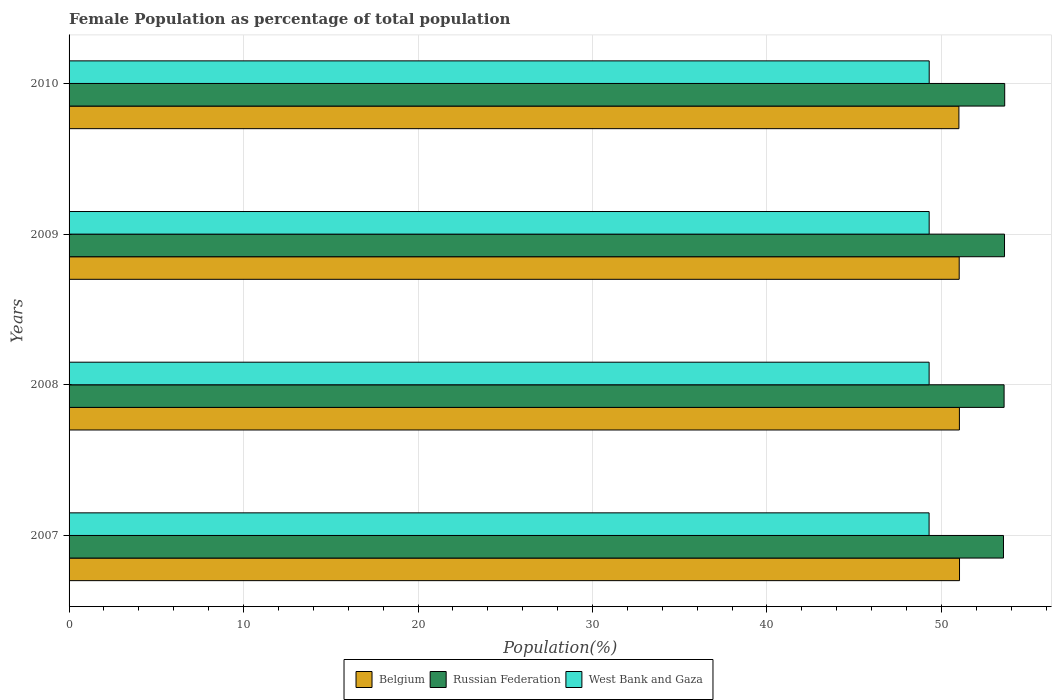How many groups of bars are there?
Your response must be concise. 4. Are the number of bars on each tick of the Y-axis equal?
Provide a succinct answer. Yes. How many bars are there on the 3rd tick from the top?
Your answer should be very brief. 3. How many bars are there on the 4th tick from the bottom?
Offer a terse response. 3. What is the label of the 2nd group of bars from the top?
Keep it short and to the point. 2009. In how many cases, is the number of bars for a given year not equal to the number of legend labels?
Provide a short and direct response. 0. What is the female population in in West Bank and Gaza in 2007?
Your response must be concise. 49.29. Across all years, what is the maximum female population in in Belgium?
Give a very brief answer. 51.03. Across all years, what is the minimum female population in in Russian Federation?
Offer a terse response. 53.55. In which year was the female population in in Russian Federation maximum?
Your answer should be very brief. 2010. What is the total female population in in West Bank and Gaza in the graph?
Your answer should be very brief. 197.17. What is the difference between the female population in in Belgium in 2008 and that in 2009?
Your answer should be compact. 0.01. What is the difference between the female population in in West Bank and Gaza in 2010 and the female population in in Russian Federation in 2008?
Offer a very short reply. -4.29. What is the average female population in in West Bank and Gaza per year?
Provide a short and direct response. 49.29. In the year 2010, what is the difference between the female population in in West Bank and Gaza and female population in in Russian Federation?
Provide a short and direct response. -4.33. What is the ratio of the female population in in Russian Federation in 2007 to that in 2009?
Your response must be concise. 1. Is the female population in in Russian Federation in 2008 less than that in 2010?
Offer a terse response. Yes. What is the difference between the highest and the second highest female population in in West Bank and Gaza?
Ensure brevity in your answer.  0. What is the difference between the highest and the lowest female population in in West Bank and Gaza?
Your answer should be compact. 0.01. What does the 2nd bar from the top in 2008 represents?
Keep it short and to the point. Russian Federation. What does the 2nd bar from the bottom in 2009 represents?
Offer a terse response. Russian Federation. Are all the bars in the graph horizontal?
Offer a terse response. Yes. Does the graph contain any zero values?
Keep it short and to the point. No. Does the graph contain grids?
Offer a terse response. Yes. Where does the legend appear in the graph?
Your answer should be compact. Bottom center. How many legend labels are there?
Your answer should be very brief. 3. What is the title of the graph?
Give a very brief answer. Female Population as percentage of total population. What is the label or title of the X-axis?
Give a very brief answer. Population(%). What is the label or title of the Y-axis?
Your answer should be compact. Years. What is the Population(%) in Belgium in 2007?
Your answer should be compact. 51.03. What is the Population(%) of Russian Federation in 2007?
Ensure brevity in your answer.  53.55. What is the Population(%) of West Bank and Gaza in 2007?
Your response must be concise. 49.29. What is the Population(%) of Belgium in 2008?
Ensure brevity in your answer.  51.03. What is the Population(%) of Russian Federation in 2008?
Keep it short and to the point. 53.59. What is the Population(%) of West Bank and Gaza in 2008?
Offer a terse response. 49.29. What is the Population(%) of Belgium in 2009?
Make the answer very short. 51.02. What is the Population(%) of Russian Federation in 2009?
Ensure brevity in your answer.  53.61. What is the Population(%) in West Bank and Gaza in 2009?
Your answer should be compact. 49.29. What is the Population(%) in Belgium in 2010?
Your answer should be very brief. 51. What is the Population(%) of Russian Federation in 2010?
Provide a short and direct response. 53.62. What is the Population(%) of West Bank and Gaza in 2010?
Your answer should be very brief. 49.3. Across all years, what is the maximum Population(%) in Belgium?
Ensure brevity in your answer.  51.03. Across all years, what is the maximum Population(%) of Russian Federation?
Keep it short and to the point. 53.62. Across all years, what is the maximum Population(%) of West Bank and Gaza?
Provide a short and direct response. 49.3. Across all years, what is the minimum Population(%) of Belgium?
Give a very brief answer. 51. Across all years, what is the minimum Population(%) in Russian Federation?
Your answer should be very brief. 53.55. Across all years, what is the minimum Population(%) in West Bank and Gaza?
Provide a short and direct response. 49.29. What is the total Population(%) of Belgium in the graph?
Ensure brevity in your answer.  204.08. What is the total Population(%) in Russian Federation in the graph?
Your answer should be very brief. 214.38. What is the total Population(%) in West Bank and Gaza in the graph?
Make the answer very short. 197.17. What is the difference between the Population(%) in Belgium in 2007 and that in 2008?
Give a very brief answer. 0.01. What is the difference between the Population(%) of Russian Federation in 2007 and that in 2008?
Keep it short and to the point. -0.04. What is the difference between the Population(%) in West Bank and Gaza in 2007 and that in 2008?
Your answer should be compact. -0. What is the difference between the Population(%) of Belgium in 2007 and that in 2009?
Make the answer very short. 0.02. What is the difference between the Population(%) of Russian Federation in 2007 and that in 2009?
Your answer should be compact. -0.06. What is the difference between the Population(%) of West Bank and Gaza in 2007 and that in 2009?
Provide a short and direct response. -0. What is the difference between the Population(%) in Belgium in 2007 and that in 2010?
Provide a short and direct response. 0.04. What is the difference between the Population(%) in Russian Federation in 2007 and that in 2010?
Provide a succinct answer. -0.07. What is the difference between the Population(%) in West Bank and Gaza in 2007 and that in 2010?
Ensure brevity in your answer.  -0.01. What is the difference between the Population(%) in Belgium in 2008 and that in 2009?
Offer a terse response. 0.01. What is the difference between the Population(%) of Russian Federation in 2008 and that in 2009?
Ensure brevity in your answer.  -0.02. What is the difference between the Population(%) of West Bank and Gaza in 2008 and that in 2009?
Provide a short and direct response. -0. What is the difference between the Population(%) in Belgium in 2008 and that in 2010?
Your answer should be very brief. 0.03. What is the difference between the Population(%) in Russian Federation in 2008 and that in 2010?
Offer a very short reply. -0.04. What is the difference between the Population(%) of West Bank and Gaza in 2008 and that in 2010?
Offer a terse response. -0. What is the difference between the Population(%) of Belgium in 2009 and that in 2010?
Provide a short and direct response. 0.02. What is the difference between the Population(%) in Russian Federation in 2009 and that in 2010?
Give a very brief answer. -0.01. What is the difference between the Population(%) in West Bank and Gaza in 2009 and that in 2010?
Keep it short and to the point. -0. What is the difference between the Population(%) in Belgium in 2007 and the Population(%) in Russian Federation in 2008?
Provide a succinct answer. -2.55. What is the difference between the Population(%) in Belgium in 2007 and the Population(%) in West Bank and Gaza in 2008?
Ensure brevity in your answer.  1.74. What is the difference between the Population(%) of Russian Federation in 2007 and the Population(%) of West Bank and Gaza in 2008?
Offer a terse response. 4.26. What is the difference between the Population(%) in Belgium in 2007 and the Population(%) in Russian Federation in 2009?
Make the answer very short. -2.58. What is the difference between the Population(%) in Belgium in 2007 and the Population(%) in West Bank and Gaza in 2009?
Your answer should be very brief. 1.74. What is the difference between the Population(%) in Russian Federation in 2007 and the Population(%) in West Bank and Gaza in 2009?
Your response must be concise. 4.26. What is the difference between the Population(%) of Belgium in 2007 and the Population(%) of Russian Federation in 2010?
Your answer should be compact. -2.59. What is the difference between the Population(%) of Belgium in 2007 and the Population(%) of West Bank and Gaza in 2010?
Give a very brief answer. 1.74. What is the difference between the Population(%) of Russian Federation in 2007 and the Population(%) of West Bank and Gaza in 2010?
Provide a succinct answer. 4.26. What is the difference between the Population(%) of Belgium in 2008 and the Population(%) of Russian Federation in 2009?
Offer a very short reply. -2.59. What is the difference between the Population(%) in Belgium in 2008 and the Population(%) in West Bank and Gaza in 2009?
Offer a terse response. 1.73. What is the difference between the Population(%) of Russian Federation in 2008 and the Population(%) of West Bank and Gaza in 2009?
Ensure brevity in your answer.  4.29. What is the difference between the Population(%) in Belgium in 2008 and the Population(%) in Russian Federation in 2010?
Your answer should be very brief. -2.6. What is the difference between the Population(%) in Belgium in 2008 and the Population(%) in West Bank and Gaza in 2010?
Your response must be concise. 1.73. What is the difference between the Population(%) of Russian Federation in 2008 and the Population(%) of West Bank and Gaza in 2010?
Your response must be concise. 4.29. What is the difference between the Population(%) in Belgium in 2009 and the Population(%) in Russian Federation in 2010?
Provide a succinct answer. -2.61. What is the difference between the Population(%) of Belgium in 2009 and the Population(%) of West Bank and Gaza in 2010?
Your answer should be very brief. 1.72. What is the difference between the Population(%) of Russian Federation in 2009 and the Population(%) of West Bank and Gaza in 2010?
Provide a succinct answer. 4.32. What is the average Population(%) in Belgium per year?
Offer a terse response. 51.02. What is the average Population(%) of Russian Federation per year?
Provide a short and direct response. 53.59. What is the average Population(%) of West Bank and Gaza per year?
Provide a short and direct response. 49.29. In the year 2007, what is the difference between the Population(%) in Belgium and Population(%) in Russian Federation?
Keep it short and to the point. -2.52. In the year 2007, what is the difference between the Population(%) in Belgium and Population(%) in West Bank and Gaza?
Provide a succinct answer. 1.74. In the year 2007, what is the difference between the Population(%) of Russian Federation and Population(%) of West Bank and Gaza?
Ensure brevity in your answer.  4.26. In the year 2008, what is the difference between the Population(%) of Belgium and Population(%) of Russian Federation?
Provide a short and direct response. -2.56. In the year 2008, what is the difference between the Population(%) in Belgium and Population(%) in West Bank and Gaza?
Your response must be concise. 1.73. In the year 2008, what is the difference between the Population(%) of Russian Federation and Population(%) of West Bank and Gaza?
Make the answer very short. 4.3. In the year 2009, what is the difference between the Population(%) of Belgium and Population(%) of Russian Federation?
Your answer should be very brief. -2.6. In the year 2009, what is the difference between the Population(%) of Belgium and Population(%) of West Bank and Gaza?
Keep it short and to the point. 1.72. In the year 2009, what is the difference between the Population(%) of Russian Federation and Population(%) of West Bank and Gaza?
Offer a very short reply. 4.32. In the year 2010, what is the difference between the Population(%) of Belgium and Population(%) of Russian Federation?
Your answer should be very brief. -2.63. In the year 2010, what is the difference between the Population(%) in Belgium and Population(%) in West Bank and Gaza?
Keep it short and to the point. 1.7. In the year 2010, what is the difference between the Population(%) of Russian Federation and Population(%) of West Bank and Gaza?
Provide a succinct answer. 4.33. What is the ratio of the Population(%) of Belgium in 2007 to that in 2008?
Ensure brevity in your answer.  1. What is the ratio of the Population(%) of West Bank and Gaza in 2007 to that in 2008?
Ensure brevity in your answer.  1. What is the ratio of the Population(%) of Belgium in 2007 to that in 2009?
Your response must be concise. 1. What is the ratio of the Population(%) of Russian Federation in 2007 to that in 2009?
Your answer should be very brief. 1. What is the ratio of the Population(%) of West Bank and Gaza in 2007 to that in 2009?
Provide a succinct answer. 1. What is the ratio of the Population(%) of Russian Federation in 2007 to that in 2010?
Your answer should be very brief. 1. What is the ratio of the Population(%) in West Bank and Gaza in 2007 to that in 2010?
Offer a very short reply. 1. What is the ratio of the Population(%) of Russian Federation in 2008 to that in 2010?
Provide a succinct answer. 1. What is the ratio of the Population(%) in West Bank and Gaza in 2008 to that in 2010?
Your response must be concise. 1. What is the ratio of the Population(%) in Russian Federation in 2009 to that in 2010?
Provide a succinct answer. 1. What is the ratio of the Population(%) in West Bank and Gaza in 2009 to that in 2010?
Ensure brevity in your answer.  1. What is the difference between the highest and the second highest Population(%) of Belgium?
Make the answer very short. 0.01. What is the difference between the highest and the second highest Population(%) in Russian Federation?
Offer a terse response. 0.01. What is the difference between the highest and the second highest Population(%) in West Bank and Gaza?
Make the answer very short. 0. What is the difference between the highest and the lowest Population(%) of Belgium?
Make the answer very short. 0.04. What is the difference between the highest and the lowest Population(%) of Russian Federation?
Give a very brief answer. 0.07. What is the difference between the highest and the lowest Population(%) in West Bank and Gaza?
Ensure brevity in your answer.  0.01. 